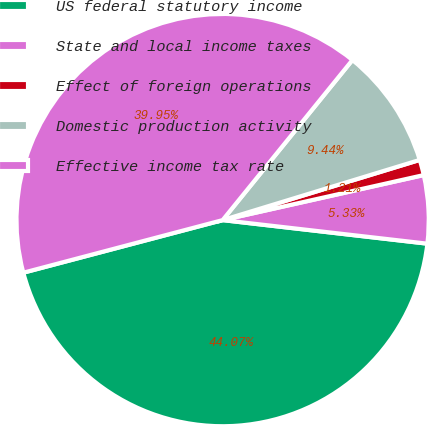Convert chart. <chart><loc_0><loc_0><loc_500><loc_500><pie_chart><fcel>US federal statutory income<fcel>State and local income taxes<fcel>Effect of foreign operations<fcel>Domestic production activity<fcel>Effective income tax rate<nl><fcel>44.07%<fcel>5.33%<fcel>1.21%<fcel>9.44%<fcel>39.95%<nl></chart> 